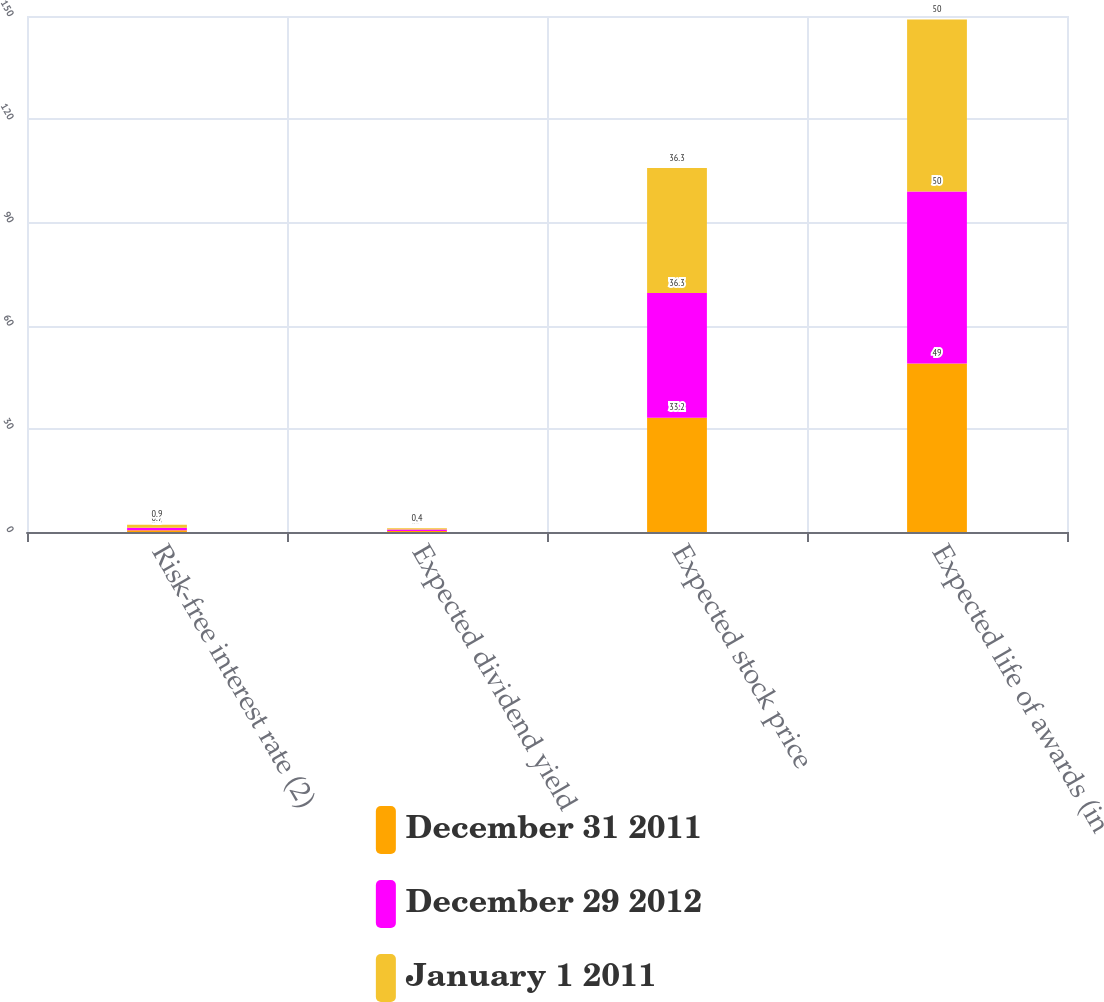Convert chart. <chart><loc_0><loc_0><loc_500><loc_500><stacked_bar_chart><ecel><fcel>Risk-free interest rate (2)<fcel>Expected dividend yield<fcel>Expected stock price<fcel>Expected life of awards (in<nl><fcel>December 31 2011<fcel>0.5<fcel>0.3<fcel>33.2<fcel>49<nl><fcel>December 29 2012<fcel>0.7<fcel>0.4<fcel>36.3<fcel>50<nl><fcel>January 1 2011<fcel>0.9<fcel>0.4<fcel>36.3<fcel>50<nl></chart> 